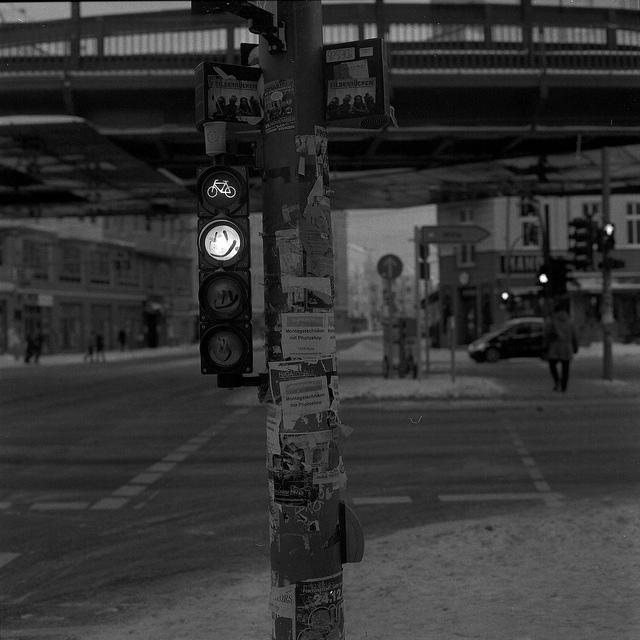How many cars are in this scene?
Answer briefly. 1. Is the bicycle light on?
Concise answer only. Yes. Is there snow on the ground in this photo?
Short answer required. Yes. What season is this?
Quick response, please. Winter. What is on the sidewalk?
Quick response, please. People. What color would this light be?
Short answer required. Red. 